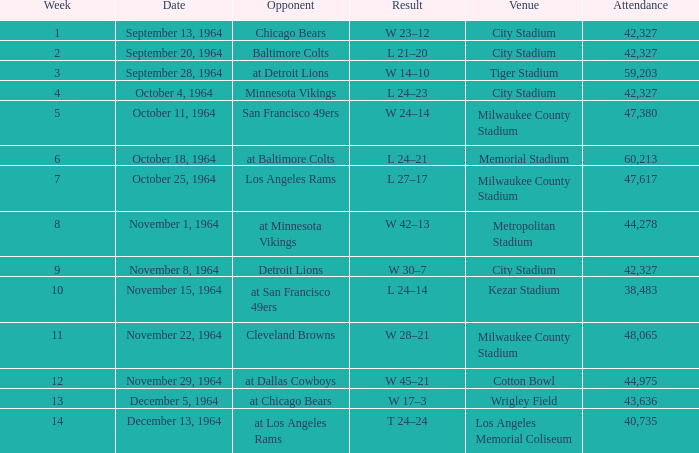How many people usually attend a week 4 game on average? 42327.0. 